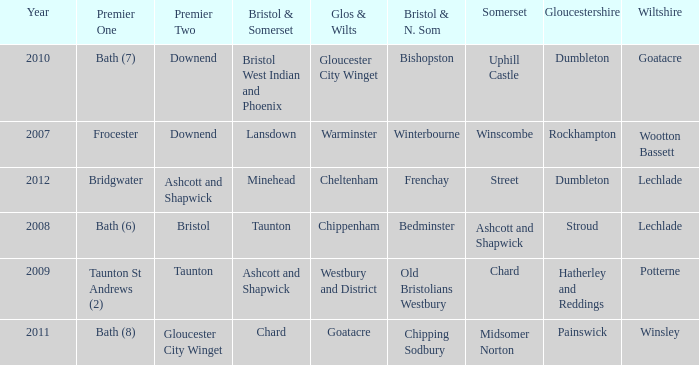What is the latest year where glos & wilts is warminster? 2007.0. 